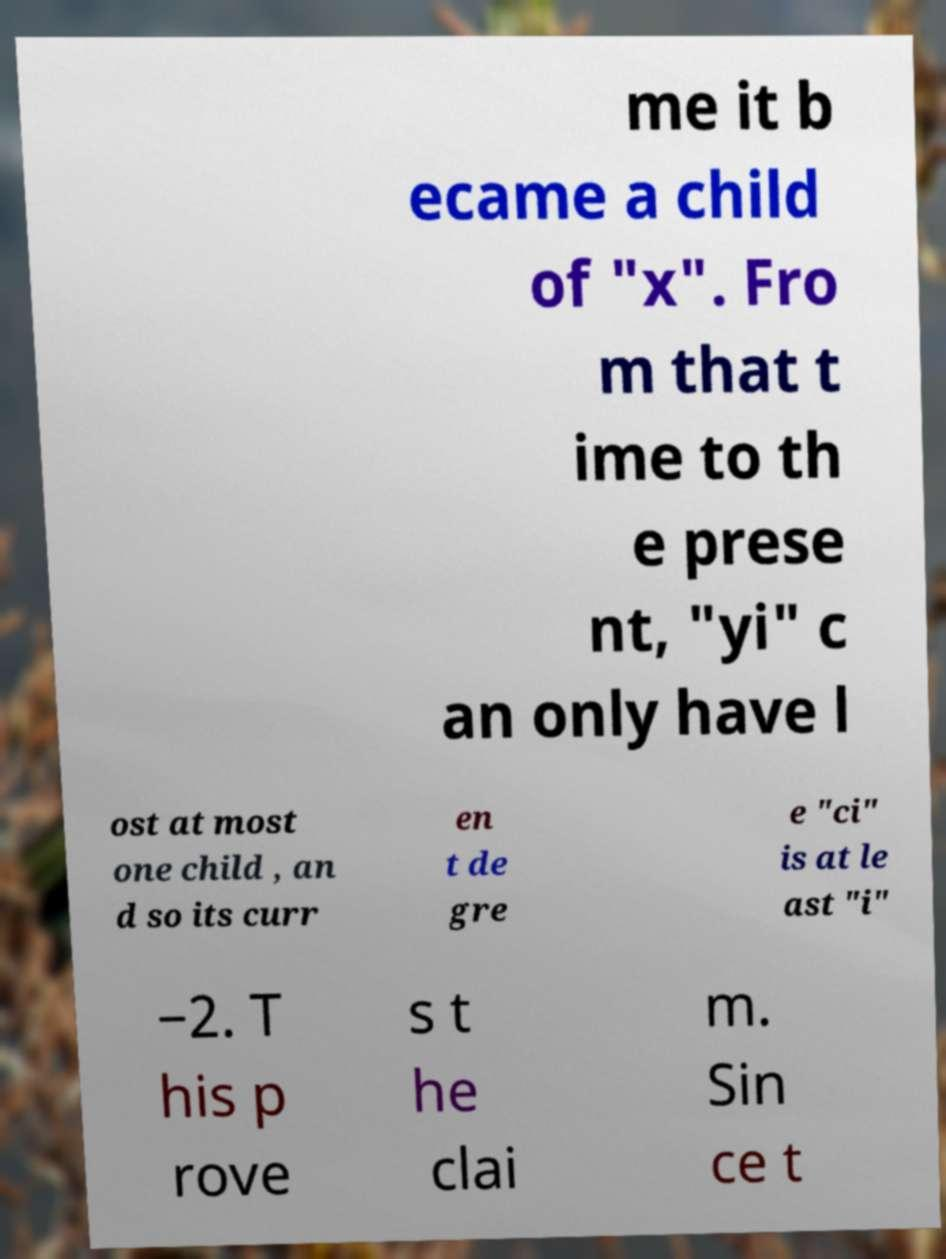Could you assist in decoding the text presented in this image and type it out clearly? me it b ecame a child of "x". Fro m that t ime to th e prese nt, "yi" c an only have l ost at most one child , an d so its curr en t de gre e "ci" is at le ast "i" −2. T his p rove s t he clai m. Sin ce t 